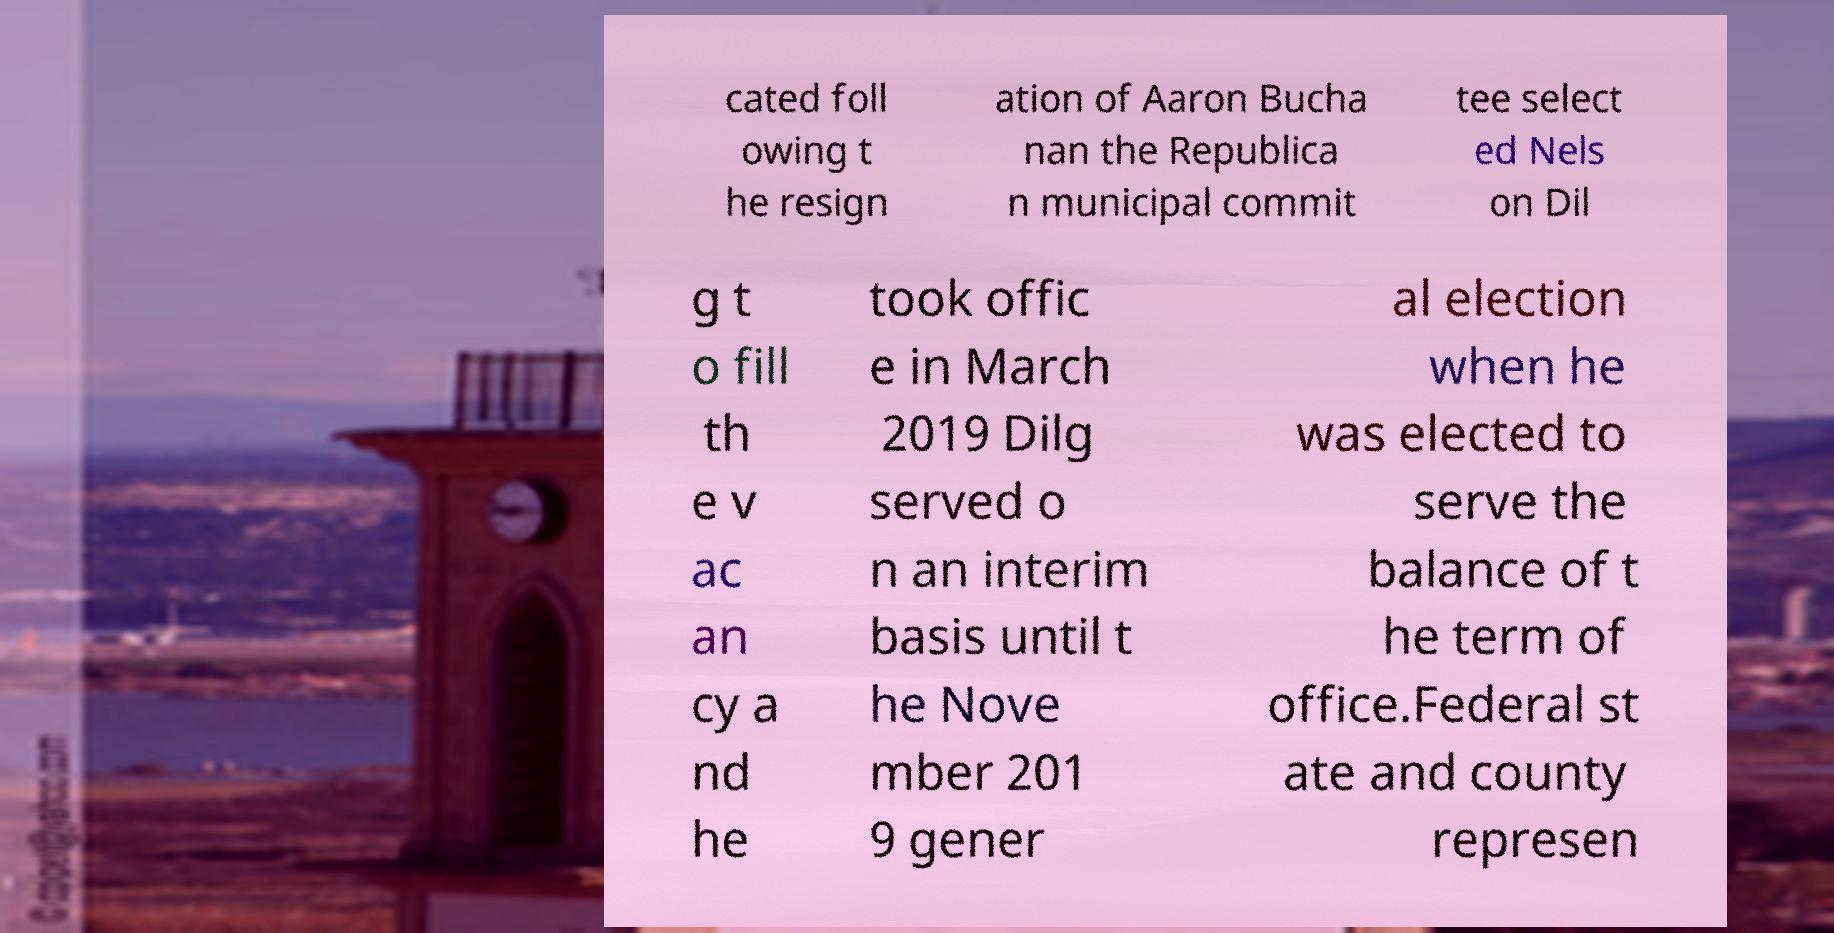I need the written content from this picture converted into text. Can you do that? cated foll owing t he resign ation of Aaron Bucha nan the Republica n municipal commit tee select ed Nels on Dil g t o fill th e v ac an cy a nd he took offic e in March 2019 Dilg served o n an interim basis until t he Nove mber 201 9 gener al election when he was elected to serve the balance of t he term of office.Federal st ate and county represen 